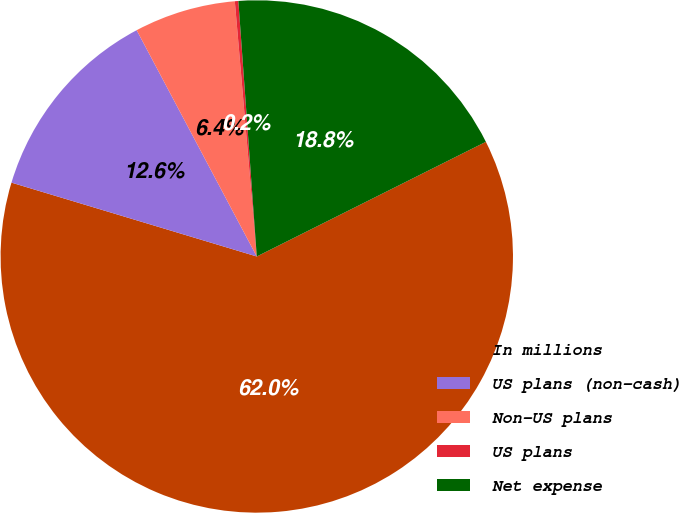Convert chart. <chart><loc_0><loc_0><loc_500><loc_500><pie_chart><fcel>In millions<fcel>US plans (non-cash)<fcel>Non-US plans<fcel>US plans<fcel>Net expense<nl><fcel>62.04%<fcel>12.58%<fcel>6.4%<fcel>0.22%<fcel>18.76%<nl></chart> 